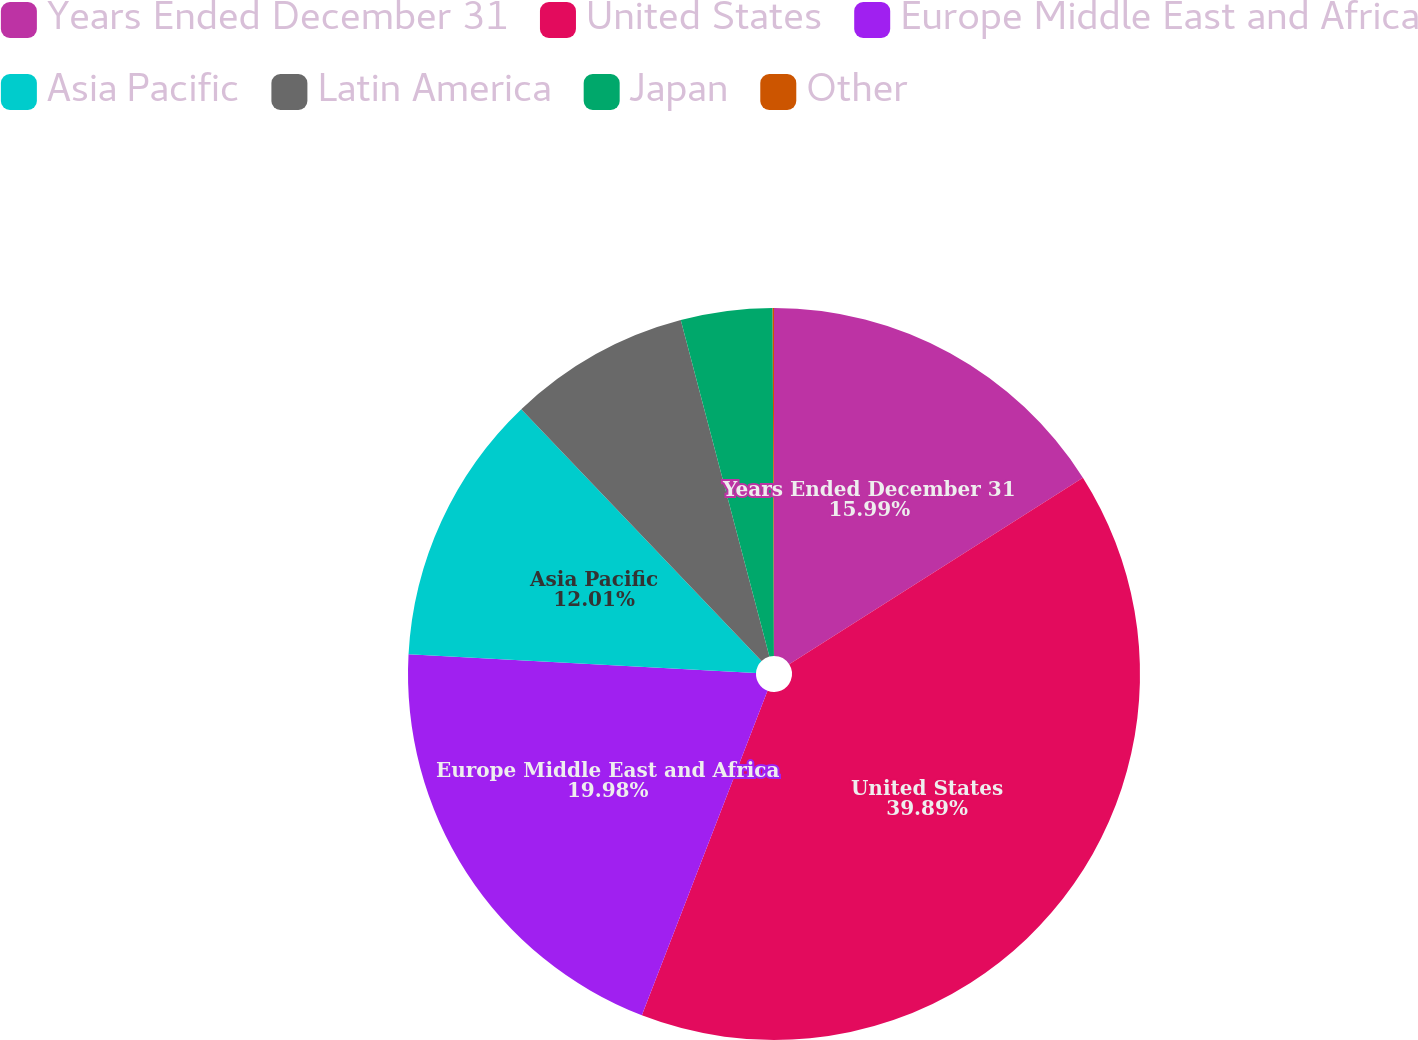Convert chart to OTSL. <chart><loc_0><loc_0><loc_500><loc_500><pie_chart><fcel>Years Ended December 31<fcel>United States<fcel>Europe Middle East and Africa<fcel>Asia Pacific<fcel>Latin America<fcel>Japan<fcel>Other<nl><fcel>15.99%<fcel>39.89%<fcel>19.98%<fcel>12.01%<fcel>8.03%<fcel>4.04%<fcel>0.06%<nl></chart> 